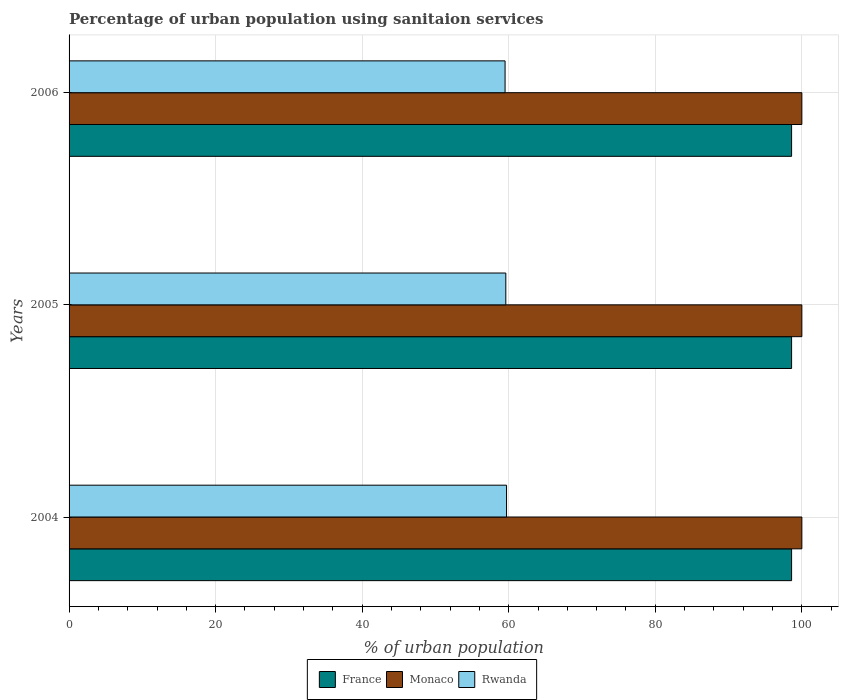How many different coloured bars are there?
Your answer should be compact. 3. How many groups of bars are there?
Offer a terse response. 3. Are the number of bars per tick equal to the number of legend labels?
Offer a very short reply. Yes. Are the number of bars on each tick of the Y-axis equal?
Give a very brief answer. Yes. In how many cases, is the number of bars for a given year not equal to the number of legend labels?
Your answer should be compact. 0. What is the percentage of urban population using sanitaion services in Rwanda in 2006?
Keep it short and to the point. 59.5. Across all years, what is the maximum percentage of urban population using sanitaion services in France?
Offer a terse response. 98.6. Across all years, what is the minimum percentage of urban population using sanitaion services in France?
Keep it short and to the point. 98.6. In which year was the percentage of urban population using sanitaion services in Rwanda maximum?
Your answer should be very brief. 2004. What is the total percentage of urban population using sanitaion services in France in the graph?
Your response must be concise. 295.8. What is the difference between the percentage of urban population using sanitaion services in Rwanda in 2006 and the percentage of urban population using sanitaion services in Monaco in 2005?
Provide a succinct answer. -40.5. What is the average percentage of urban population using sanitaion services in Rwanda per year?
Ensure brevity in your answer.  59.6. In the year 2005, what is the difference between the percentage of urban population using sanitaion services in France and percentage of urban population using sanitaion services in Rwanda?
Your response must be concise. 39. What is the ratio of the percentage of urban population using sanitaion services in Rwanda in 2005 to that in 2006?
Make the answer very short. 1. Is the percentage of urban population using sanitaion services in Rwanda in 2005 less than that in 2006?
Give a very brief answer. No. What is the difference between the highest and the second highest percentage of urban population using sanitaion services in Rwanda?
Your answer should be very brief. 0.1. What is the difference between the highest and the lowest percentage of urban population using sanitaion services in France?
Ensure brevity in your answer.  0. In how many years, is the percentage of urban population using sanitaion services in Rwanda greater than the average percentage of urban population using sanitaion services in Rwanda taken over all years?
Offer a very short reply. 1. Is the sum of the percentage of urban population using sanitaion services in Monaco in 2004 and 2005 greater than the maximum percentage of urban population using sanitaion services in Rwanda across all years?
Your answer should be very brief. Yes. What does the 2nd bar from the bottom in 2004 represents?
Offer a terse response. Monaco. How many bars are there?
Keep it short and to the point. 9. Are all the bars in the graph horizontal?
Make the answer very short. Yes. How many years are there in the graph?
Provide a succinct answer. 3. What is the difference between two consecutive major ticks on the X-axis?
Your response must be concise. 20. Does the graph contain any zero values?
Give a very brief answer. No. Does the graph contain grids?
Provide a succinct answer. Yes. Where does the legend appear in the graph?
Provide a succinct answer. Bottom center. How many legend labels are there?
Ensure brevity in your answer.  3. How are the legend labels stacked?
Provide a succinct answer. Horizontal. What is the title of the graph?
Provide a short and direct response. Percentage of urban population using sanitaion services. Does "Mauritius" appear as one of the legend labels in the graph?
Make the answer very short. No. What is the label or title of the X-axis?
Offer a very short reply. % of urban population. What is the % of urban population in France in 2004?
Give a very brief answer. 98.6. What is the % of urban population in Monaco in 2004?
Offer a terse response. 100. What is the % of urban population in Rwanda in 2004?
Provide a short and direct response. 59.7. What is the % of urban population of France in 2005?
Provide a short and direct response. 98.6. What is the % of urban population in Monaco in 2005?
Your answer should be very brief. 100. What is the % of urban population in Rwanda in 2005?
Keep it short and to the point. 59.6. What is the % of urban population of France in 2006?
Your response must be concise. 98.6. What is the % of urban population in Monaco in 2006?
Your answer should be compact. 100. What is the % of urban population in Rwanda in 2006?
Provide a succinct answer. 59.5. Across all years, what is the maximum % of urban population of France?
Make the answer very short. 98.6. Across all years, what is the maximum % of urban population in Rwanda?
Your answer should be very brief. 59.7. Across all years, what is the minimum % of urban population in France?
Your response must be concise. 98.6. Across all years, what is the minimum % of urban population of Monaco?
Your response must be concise. 100. Across all years, what is the minimum % of urban population of Rwanda?
Offer a terse response. 59.5. What is the total % of urban population in France in the graph?
Offer a terse response. 295.8. What is the total % of urban population in Monaco in the graph?
Ensure brevity in your answer.  300. What is the total % of urban population of Rwanda in the graph?
Offer a very short reply. 178.8. What is the difference between the % of urban population in France in 2004 and that in 2005?
Ensure brevity in your answer.  0. What is the difference between the % of urban population of Monaco in 2004 and that in 2005?
Keep it short and to the point. 0. What is the difference between the % of urban population of France in 2004 and that in 2006?
Your answer should be very brief. 0. What is the difference between the % of urban population in France in 2004 and the % of urban population in Rwanda in 2005?
Offer a terse response. 39. What is the difference between the % of urban population of Monaco in 2004 and the % of urban population of Rwanda in 2005?
Your answer should be very brief. 40.4. What is the difference between the % of urban population in France in 2004 and the % of urban population in Rwanda in 2006?
Your answer should be compact. 39.1. What is the difference between the % of urban population in Monaco in 2004 and the % of urban population in Rwanda in 2006?
Provide a short and direct response. 40.5. What is the difference between the % of urban population in France in 2005 and the % of urban population in Monaco in 2006?
Your answer should be compact. -1.4. What is the difference between the % of urban population in France in 2005 and the % of urban population in Rwanda in 2006?
Keep it short and to the point. 39.1. What is the difference between the % of urban population of Monaco in 2005 and the % of urban population of Rwanda in 2006?
Ensure brevity in your answer.  40.5. What is the average % of urban population of France per year?
Ensure brevity in your answer.  98.6. What is the average % of urban population in Rwanda per year?
Offer a very short reply. 59.6. In the year 2004, what is the difference between the % of urban population of France and % of urban population of Monaco?
Give a very brief answer. -1.4. In the year 2004, what is the difference between the % of urban population of France and % of urban population of Rwanda?
Make the answer very short. 38.9. In the year 2004, what is the difference between the % of urban population in Monaco and % of urban population in Rwanda?
Offer a very short reply. 40.3. In the year 2005, what is the difference between the % of urban population in France and % of urban population in Rwanda?
Make the answer very short. 39. In the year 2005, what is the difference between the % of urban population in Monaco and % of urban population in Rwanda?
Your response must be concise. 40.4. In the year 2006, what is the difference between the % of urban population in France and % of urban population in Rwanda?
Provide a succinct answer. 39.1. In the year 2006, what is the difference between the % of urban population of Monaco and % of urban population of Rwanda?
Your response must be concise. 40.5. What is the ratio of the % of urban population of Rwanda in 2004 to that in 2005?
Your answer should be compact. 1. What is the ratio of the % of urban population in France in 2004 to that in 2006?
Make the answer very short. 1. What is the ratio of the % of urban population of Monaco in 2004 to that in 2006?
Provide a succinct answer. 1. What is the ratio of the % of urban population of Rwanda in 2004 to that in 2006?
Provide a short and direct response. 1. What is the ratio of the % of urban population of France in 2005 to that in 2006?
Make the answer very short. 1. What is the ratio of the % of urban population of Monaco in 2005 to that in 2006?
Offer a terse response. 1. What is the ratio of the % of urban population in Rwanda in 2005 to that in 2006?
Provide a succinct answer. 1. What is the difference between the highest and the second highest % of urban population in France?
Your response must be concise. 0. 